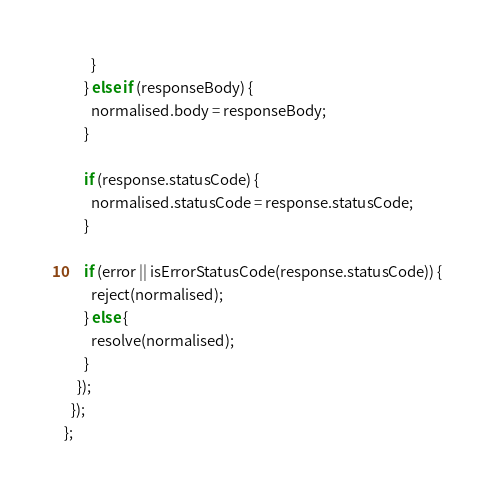Convert code to text. <code><loc_0><loc_0><loc_500><loc_500><_JavaScript_>        }
      } else if (responseBody) {
        normalised.body = responseBody;
      }

      if (response.statusCode) {
        normalised.statusCode = response.statusCode;
      }

      if (error || isErrorStatusCode(response.statusCode)) {
        reject(normalised);
      } else {
        resolve(normalised);
      }
    });
  });
};
</code> 